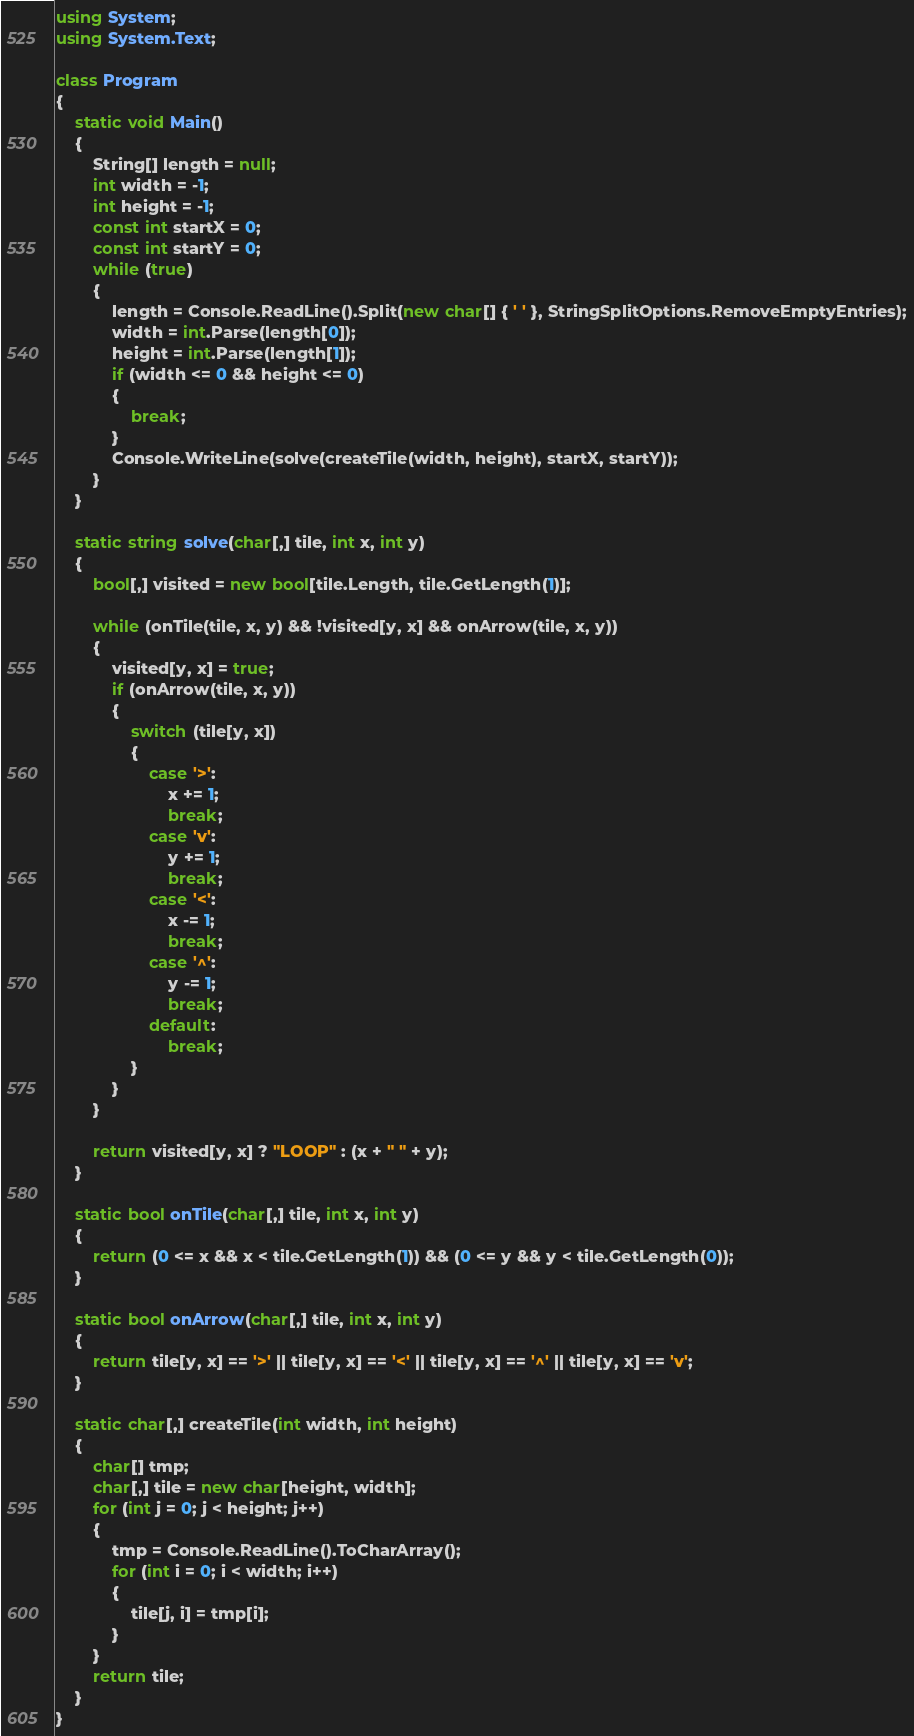Convert code to text. <code><loc_0><loc_0><loc_500><loc_500><_C#_>using System;
using System.Text;

class Program
{
    static void Main()
    {
        String[] length = null;
        int width = -1;
        int height = -1;
        const int startX = 0;
        const int startY = 0;
        while (true)
        {
            length = Console.ReadLine().Split(new char[] { ' ' }, StringSplitOptions.RemoveEmptyEntries);
            width = int.Parse(length[0]);
            height = int.Parse(length[1]);
            if (width <= 0 && height <= 0)
            {
                break;
            }
            Console.WriteLine(solve(createTile(width, height), startX, startY));
        }
    }

    static string solve(char[,] tile, int x, int y)
    {
        bool[,] visited = new bool[tile.Length, tile.GetLength(1)];

        while (onTile(tile, x, y) && !visited[y, x] && onArrow(tile, x, y))
        {
            visited[y, x] = true;
            if (onArrow(tile, x, y))
            {
                switch (tile[y, x])
                {
                    case '>':
                        x += 1;
                        break;
                    case 'v':
                        y += 1;
                        break;
                    case '<':
                        x -= 1;
                        break;
                    case '^':
                        y -= 1;
                        break;
                    default:
                        break;
                }
            }
        }

        return visited[y, x] ? "LOOP" : (x + " " + y);
    }

    static bool onTile(char[,] tile, int x, int y)
    {
        return (0 <= x && x < tile.GetLength(1)) && (0 <= y && y < tile.GetLength(0));
    }

    static bool onArrow(char[,] tile, int x, int y)
    {
        return tile[y, x] == '>' || tile[y, x] == '<' || tile[y, x] == '^' || tile[y, x] == 'v';
    }

    static char[,] createTile(int width, int height)
    {
        char[] tmp;
        char[,] tile = new char[height, width];
        for (int j = 0; j < height; j++)
        {
            tmp = Console.ReadLine().ToCharArray();
            for (int i = 0; i < width; i++)
            {
                tile[j, i] = tmp[i];
            }
        }
        return tile;
    }
}</code> 